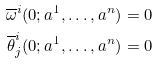Convert formula to latex. <formula><loc_0><loc_0><loc_500><loc_500>\overline { \omega } ^ { i } ( 0 ; a ^ { 1 } , \dots , a ^ { n } ) & = 0 \\ \overline { \theta } ^ { i } _ { j } ( 0 ; a ^ { 1 } , \dots , a ^ { n } ) & = 0</formula> 